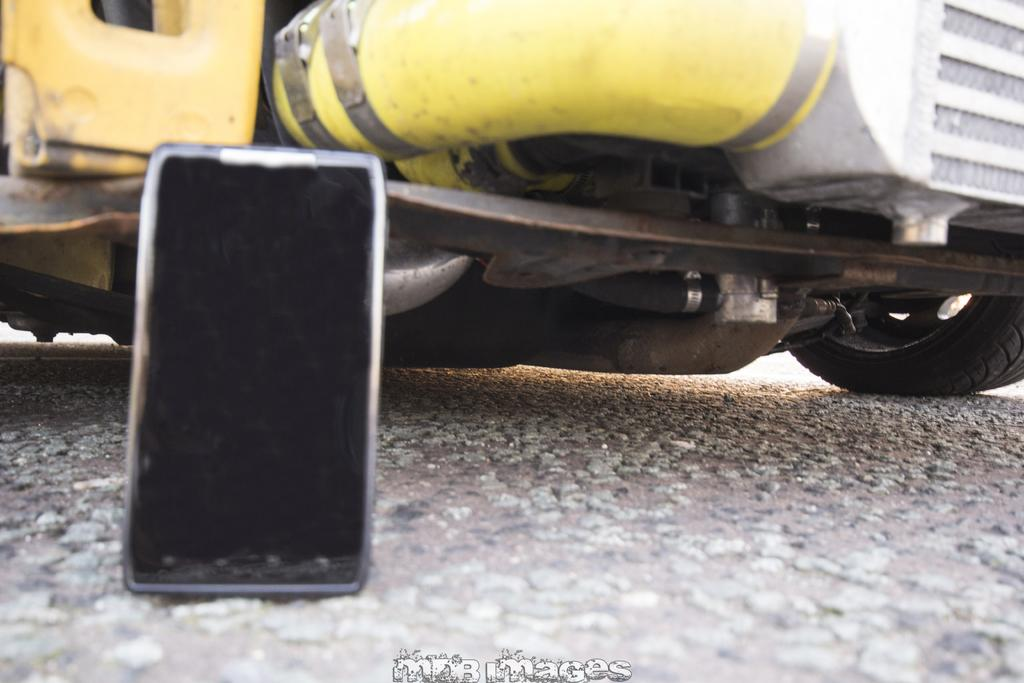What is the main object in the image? There is a mobile in the image. What else can be seen in the background of the image? There is a part of a vehicle in the background of the image. Is there any text present in the image? Yes, there is text at the bottom of the image. What type of dress is the person wearing in the image? There is no person or dress present in the image; it features a mobile and a part of a vehicle in the background. 